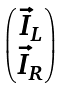Convert formula to latex. <formula><loc_0><loc_0><loc_500><loc_500>\begin{pmatrix} \vec { I } _ { L } \\ \vec { I } _ { R } \end{pmatrix}</formula> 